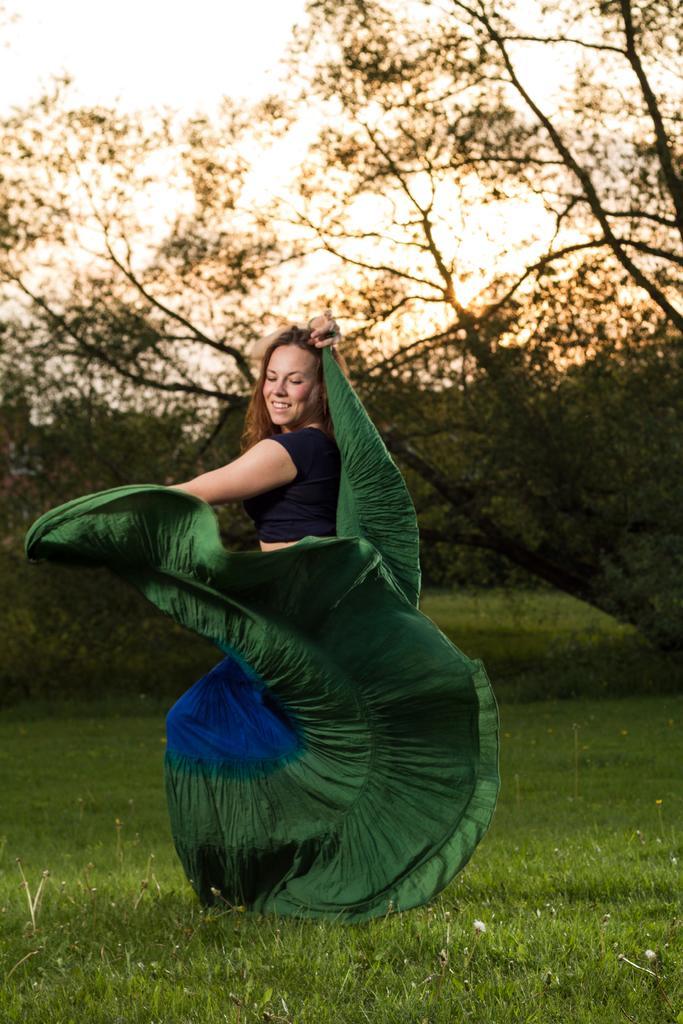Can you describe this image briefly? In this image at front there is a woman standing on the surface of the grass. At the background there are trees and sky. 